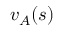<formula> <loc_0><loc_0><loc_500><loc_500>v _ { A } ( s )</formula> 